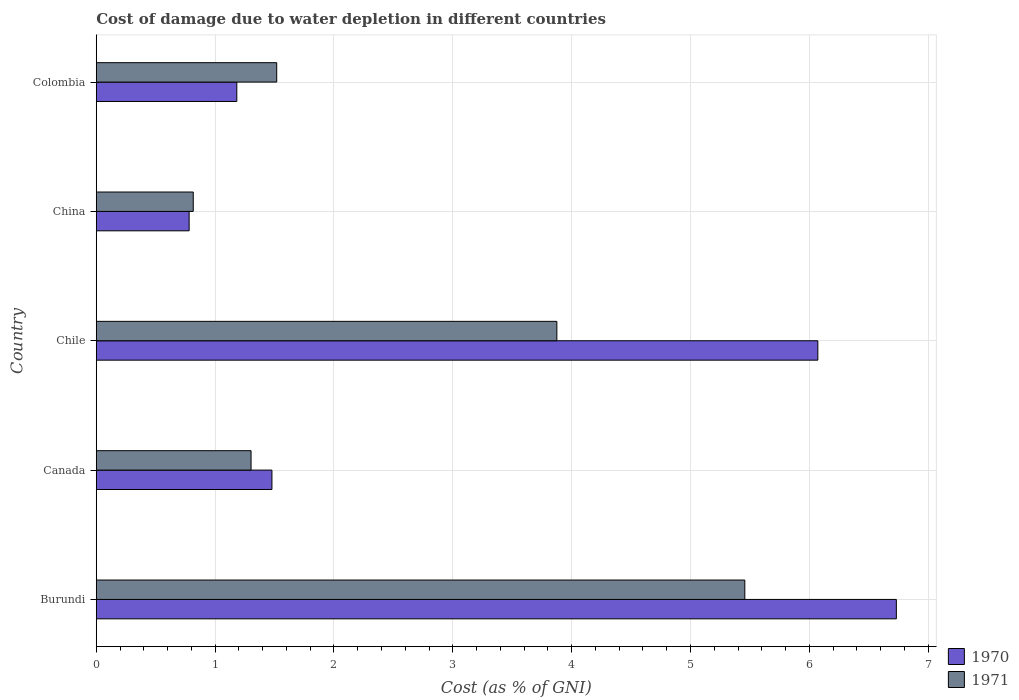How many groups of bars are there?
Ensure brevity in your answer.  5. Are the number of bars on each tick of the Y-axis equal?
Your answer should be very brief. Yes. How many bars are there on the 3rd tick from the top?
Provide a succinct answer. 2. What is the cost of damage caused due to water depletion in 1970 in Colombia?
Offer a terse response. 1.18. Across all countries, what is the maximum cost of damage caused due to water depletion in 1971?
Offer a very short reply. 5.46. Across all countries, what is the minimum cost of damage caused due to water depletion in 1970?
Provide a short and direct response. 0.78. In which country was the cost of damage caused due to water depletion in 1970 maximum?
Give a very brief answer. Burundi. What is the total cost of damage caused due to water depletion in 1970 in the graph?
Provide a succinct answer. 16.25. What is the difference between the cost of damage caused due to water depletion in 1971 in Canada and that in Chile?
Provide a short and direct response. -2.57. What is the difference between the cost of damage caused due to water depletion in 1971 in Burundi and the cost of damage caused due to water depletion in 1970 in China?
Your answer should be compact. 4.68. What is the average cost of damage caused due to water depletion in 1971 per country?
Offer a terse response. 2.59. What is the difference between the cost of damage caused due to water depletion in 1970 and cost of damage caused due to water depletion in 1971 in Burundi?
Provide a succinct answer. 1.28. In how many countries, is the cost of damage caused due to water depletion in 1970 greater than 4 %?
Make the answer very short. 2. What is the ratio of the cost of damage caused due to water depletion in 1971 in Canada to that in Chile?
Your answer should be very brief. 0.34. What is the difference between the highest and the second highest cost of damage caused due to water depletion in 1970?
Your answer should be very brief. 0.66. What is the difference between the highest and the lowest cost of damage caused due to water depletion in 1971?
Your answer should be very brief. 4.64. In how many countries, is the cost of damage caused due to water depletion in 1971 greater than the average cost of damage caused due to water depletion in 1971 taken over all countries?
Keep it short and to the point. 2. How many bars are there?
Offer a terse response. 10. How many countries are there in the graph?
Provide a short and direct response. 5. What is the difference between two consecutive major ticks on the X-axis?
Provide a short and direct response. 1. Does the graph contain grids?
Your answer should be very brief. Yes. Where does the legend appear in the graph?
Offer a terse response. Bottom right. What is the title of the graph?
Give a very brief answer. Cost of damage due to water depletion in different countries. Does "2009" appear as one of the legend labels in the graph?
Provide a short and direct response. No. What is the label or title of the X-axis?
Provide a succinct answer. Cost (as % of GNI). What is the Cost (as % of GNI) of 1970 in Burundi?
Make the answer very short. 6.73. What is the Cost (as % of GNI) in 1971 in Burundi?
Offer a terse response. 5.46. What is the Cost (as % of GNI) of 1970 in Canada?
Offer a very short reply. 1.48. What is the Cost (as % of GNI) of 1971 in Canada?
Give a very brief answer. 1.3. What is the Cost (as % of GNI) in 1970 in Chile?
Make the answer very short. 6.07. What is the Cost (as % of GNI) of 1971 in Chile?
Your response must be concise. 3.88. What is the Cost (as % of GNI) of 1970 in China?
Your answer should be compact. 0.78. What is the Cost (as % of GNI) of 1971 in China?
Provide a succinct answer. 0.82. What is the Cost (as % of GNI) of 1970 in Colombia?
Your answer should be compact. 1.18. What is the Cost (as % of GNI) of 1971 in Colombia?
Give a very brief answer. 1.52. Across all countries, what is the maximum Cost (as % of GNI) of 1970?
Keep it short and to the point. 6.73. Across all countries, what is the maximum Cost (as % of GNI) in 1971?
Keep it short and to the point. 5.46. Across all countries, what is the minimum Cost (as % of GNI) in 1970?
Offer a very short reply. 0.78. Across all countries, what is the minimum Cost (as % of GNI) of 1971?
Keep it short and to the point. 0.82. What is the total Cost (as % of GNI) of 1970 in the graph?
Offer a very short reply. 16.25. What is the total Cost (as % of GNI) in 1971 in the graph?
Ensure brevity in your answer.  12.97. What is the difference between the Cost (as % of GNI) of 1970 in Burundi and that in Canada?
Provide a short and direct response. 5.25. What is the difference between the Cost (as % of GNI) in 1971 in Burundi and that in Canada?
Offer a very short reply. 4.15. What is the difference between the Cost (as % of GNI) of 1970 in Burundi and that in Chile?
Make the answer very short. 0.66. What is the difference between the Cost (as % of GNI) of 1971 in Burundi and that in Chile?
Provide a succinct answer. 1.58. What is the difference between the Cost (as % of GNI) in 1970 in Burundi and that in China?
Keep it short and to the point. 5.95. What is the difference between the Cost (as % of GNI) in 1971 in Burundi and that in China?
Provide a succinct answer. 4.64. What is the difference between the Cost (as % of GNI) of 1970 in Burundi and that in Colombia?
Provide a short and direct response. 5.55. What is the difference between the Cost (as % of GNI) in 1971 in Burundi and that in Colombia?
Your answer should be very brief. 3.94. What is the difference between the Cost (as % of GNI) of 1970 in Canada and that in Chile?
Offer a terse response. -4.59. What is the difference between the Cost (as % of GNI) of 1971 in Canada and that in Chile?
Make the answer very short. -2.57. What is the difference between the Cost (as % of GNI) of 1970 in Canada and that in China?
Your response must be concise. 0.7. What is the difference between the Cost (as % of GNI) in 1971 in Canada and that in China?
Offer a terse response. 0.49. What is the difference between the Cost (as % of GNI) of 1970 in Canada and that in Colombia?
Provide a succinct answer. 0.3. What is the difference between the Cost (as % of GNI) in 1971 in Canada and that in Colombia?
Your answer should be compact. -0.22. What is the difference between the Cost (as % of GNI) in 1970 in Chile and that in China?
Your answer should be compact. 5.29. What is the difference between the Cost (as % of GNI) of 1971 in Chile and that in China?
Keep it short and to the point. 3.06. What is the difference between the Cost (as % of GNI) of 1970 in Chile and that in Colombia?
Ensure brevity in your answer.  4.89. What is the difference between the Cost (as % of GNI) of 1971 in Chile and that in Colombia?
Your response must be concise. 2.36. What is the difference between the Cost (as % of GNI) of 1970 in China and that in Colombia?
Provide a succinct answer. -0.4. What is the difference between the Cost (as % of GNI) in 1971 in China and that in Colombia?
Ensure brevity in your answer.  -0.7. What is the difference between the Cost (as % of GNI) of 1970 in Burundi and the Cost (as % of GNI) of 1971 in Canada?
Your response must be concise. 5.43. What is the difference between the Cost (as % of GNI) of 1970 in Burundi and the Cost (as % of GNI) of 1971 in Chile?
Offer a very short reply. 2.86. What is the difference between the Cost (as % of GNI) of 1970 in Burundi and the Cost (as % of GNI) of 1971 in China?
Your response must be concise. 5.92. What is the difference between the Cost (as % of GNI) in 1970 in Burundi and the Cost (as % of GNI) in 1971 in Colombia?
Provide a succinct answer. 5.21. What is the difference between the Cost (as % of GNI) in 1970 in Canada and the Cost (as % of GNI) in 1971 in Chile?
Keep it short and to the point. -2.4. What is the difference between the Cost (as % of GNI) in 1970 in Canada and the Cost (as % of GNI) in 1971 in China?
Make the answer very short. 0.66. What is the difference between the Cost (as % of GNI) in 1970 in Canada and the Cost (as % of GNI) in 1971 in Colombia?
Ensure brevity in your answer.  -0.04. What is the difference between the Cost (as % of GNI) in 1970 in Chile and the Cost (as % of GNI) in 1971 in China?
Keep it short and to the point. 5.26. What is the difference between the Cost (as % of GNI) of 1970 in Chile and the Cost (as % of GNI) of 1971 in Colombia?
Offer a very short reply. 4.55. What is the difference between the Cost (as % of GNI) of 1970 in China and the Cost (as % of GNI) of 1971 in Colombia?
Your answer should be compact. -0.74. What is the average Cost (as % of GNI) in 1970 per country?
Your response must be concise. 3.25. What is the average Cost (as % of GNI) in 1971 per country?
Provide a succinct answer. 2.59. What is the difference between the Cost (as % of GNI) of 1970 and Cost (as % of GNI) of 1971 in Burundi?
Ensure brevity in your answer.  1.28. What is the difference between the Cost (as % of GNI) of 1970 and Cost (as % of GNI) of 1971 in Canada?
Offer a terse response. 0.18. What is the difference between the Cost (as % of GNI) of 1970 and Cost (as % of GNI) of 1971 in Chile?
Provide a succinct answer. 2.2. What is the difference between the Cost (as % of GNI) in 1970 and Cost (as % of GNI) in 1971 in China?
Provide a short and direct response. -0.03. What is the difference between the Cost (as % of GNI) of 1970 and Cost (as % of GNI) of 1971 in Colombia?
Your answer should be very brief. -0.34. What is the ratio of the Cost (as % of GNI) of 1970 in Burundi to that in Canada?
Offer a terse response. 4.55. What is the ratio of the Cost (as % of GNI) in 1971 in Burundi to that in Canada?
Make the answer very short. 4.19. What is the ratio of the Cost (as % of GNI) in 1970 in Burundi to that in Chile?
Your answer should be compact. 1.11. What is the ratio of the Cost (as % of GNI) in 1971 in Burundi to that in Chile?
Give a very brief answer. 1.41. What is the ratio of the Cost (as % of GNI) in 1970 in Burundi to that in China?
Ensure brevity in your answer.  8.61. What is the ratio of the Cost (as % of GNI) in 1971 in Burundi to that in China?
Offer a terse response. 6.69. What is the ratio of the Cost (as % of GNI) in 1970 in Burundi to that in Colombia?
Offer a very short reply. 5.69. What is the ratio of the Cost (as % of GNI) in 1971 in Burundi to that in Colombia?
Your response must be concise. 3.59. What is the ratio of the Cost (as % of GNI) in 1970 in Canada to that in Chile?
Keep it short and to the point. 0.24. What is the ratio of the Cost (as % of GNI) of 1971 in Canada to that in Chile?
Offer a very short reply. 0.34. What is the ratio of the Cost (as % of GNI) in 1970 in Canada to that in China?
Your answer should be compact. 1.89. What is the ratio of the Cost (as % of GNI) of 1971 in Canada to that in China?
Provide a succinct answer. 1.6. What is the ratio of the Cost (as % of GNI) in 1970 in Canada to that in Colombia?
Provide a succinct answer. 1.25. What is the ratio of the Cost (as % of GNI) in 1971 in Canada to that in Colombia?
Give a very brief answer. 0.86. What is the ratio of the Cost (as % of GNI) in 1970 in Chile to that in China?
Ensure brevity in your answer.  7.77. What is the ratio of the Cost (as % of GNI) in 1971 in Chile to that in China?
Ensure brevity in your answer.  4.75. What is the ratio of the Cost (as % of GNI) in 1970 in Chile to that in Colombia?
Offer a very short reply. 5.13. What is the ratio of the Cost (as % of GNI) in 1971 in Chile to that in Colombia?
Provide a short and direct response. 2.55. What is the ratio of the Cost (as % of GNI) in 1970 in China to that in Colombia?
Keep it short and to the point. 0.66. What is the ratio of the Cost (as % of GNI) in 1971 in China to that in Colombia?
Your answer should be very brief. 0.54. What is the difference between the highest and the second highest Cost (as % of GNI) of 1970?
Ensure brevity in your answer.  0.66. What is the difference between the highest and the second highest Cost (as % of GNI) of 1971?
Offer a very short reply. 1.58. What is the difference between the highest and the lowest Cost (as % of GNI) of 1970?
Your answer should be very brief. 5.95. What is the difference between the highest and the lowest Cost (as % of GNI) of 1971?
Your response must be concise. 4.64. 